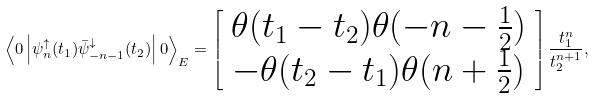<formula> <loc_0><loc_0><loc_500><loc_500>\left \langle 0 \left | \psi _ { n } ^ { \uparrow } ( t _ { 1 } ) \bar { \psi } _ { - n - 1 } ^ { \downarrow } ( t _ { 2 } ) \right | 0 \right \rangle _ { E } = \left [ \begin{array} { c } \theta ( t _ { 1 } - t _ { 2 } ) \theta ( - n - \frac { 1 } { 2 } ) \\ - \theta ( t _ { 2 } - t _ { 1 } ) \theta ( n + \frac { 1 } { 2 } ) \end{array} \right ] \frac { t _ { 1 } ^ { n } } { t _ { 2 } ^ { n + 1 } } ,</formula> 